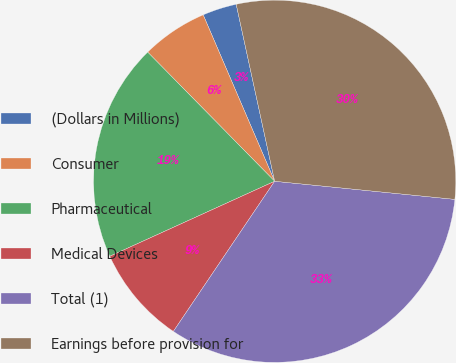Convert chart. <chart><loc_0><loc_0><loc_500><loc_500><pie_chart><fcel>(Dollars in Millions)<fcel>Consumer<fcel>Pharmaceutical<fcel>Medical Devices<fcel>Total (1)<fcel>Earnings before provision for<nl><fcel>3.05%<fcel>5.91%<fcel>19.43%<fcel>8.76%<fcel>32.85%<fcel>30.0%<nl></chart> 